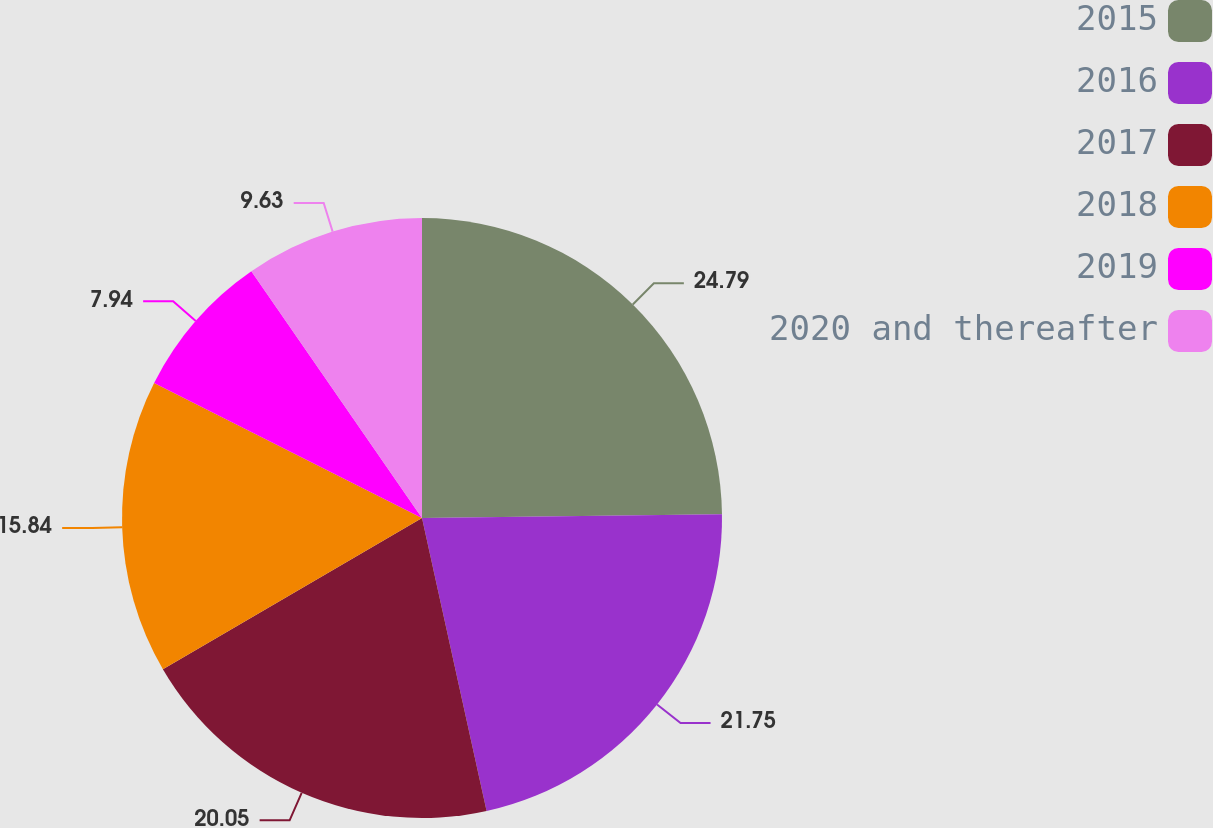Convert chart to OTSL. <chart><loc_0><loc_0><loc_500><loc_500><pie_chart><fcel>2015<fcel>2016<fcel>2017<fcel>2018<fcel>2019<fcel>2020 and thereafter<nl><fcel>24.8%<fcel>21.75%<fcel>20.05%<fcel>15.84%<fcel>7.94%<fcel>9.63%<nl></chart> 